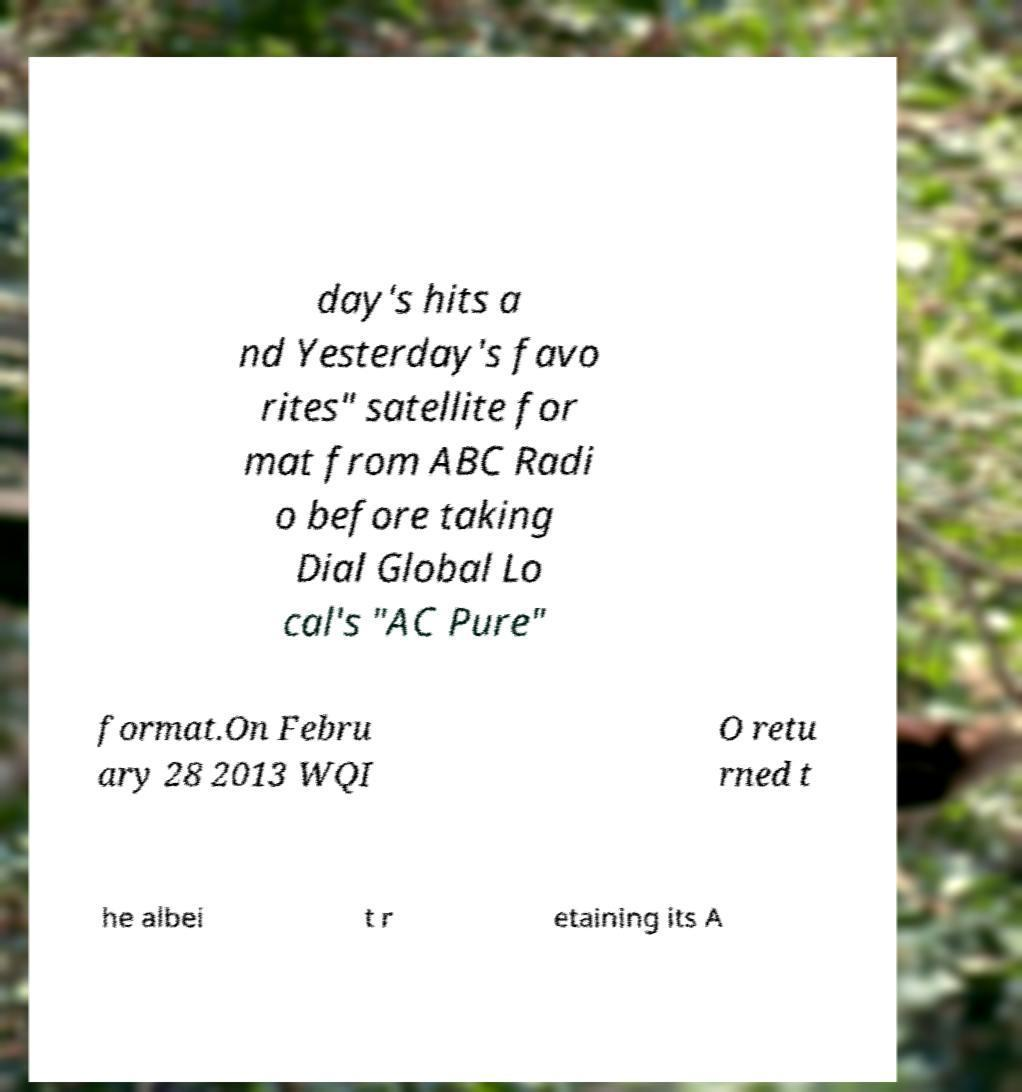Please read and relay the text visible in this image. What does it say? day's hits a nd Yesterday's favo rites" satellite for mat from ABC Radi o before taking Dial Global Lo cal's "AC Pure" format.On Febru ary 28 2013 WQI O retu rned t he albei t r etaining its A 